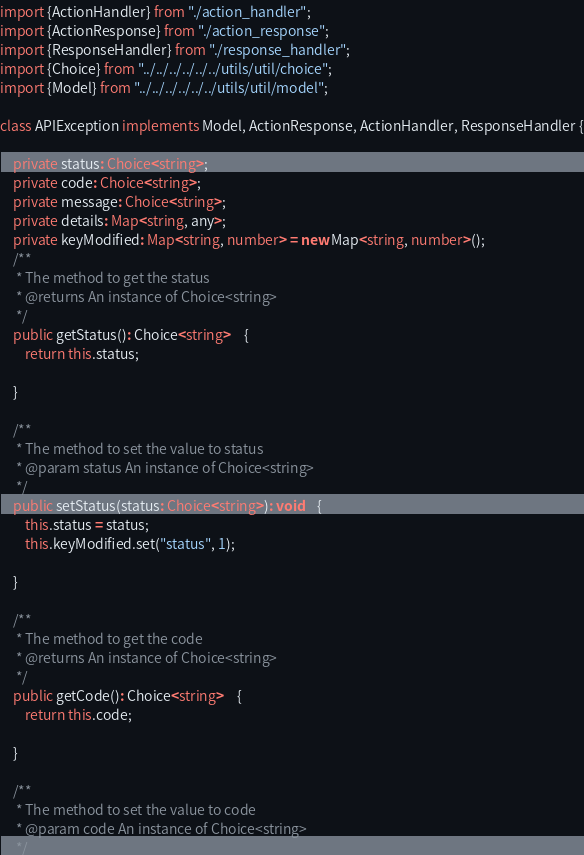<code> <loc_0><loc_0><loc_500><loc_500><_TypeScript_>import {ActionHandler} from "./action_handler";
import {ActionResponse} from "./action_response";
import {ResponseHandler} from "./response_handler";
import {Choice} from "../../../../../../utils/util/choice";
import {Model} from "../../../../../../utils/util/model";

class APIException implements Model, ActionResponse, ActionHandler, ResponseHandler {

	private status: Choice<string>;
	private code: Choice<string>;
	private message: Choice<string>;
	private details: Map<string, any>;
	private keyModified: Map<string, number> = new Map<string, number>();
	/**
	 * The method to get the status
	 * @returns An instance of Choice<string>
	 */
	public getStatus(): Choice<string>	{
		return this.status;

	}

	/**
	 * The method to set the value to status
	 * @param status An instance of Choice<string>
	 */
	public setStatus(status: Choice<string>): void	{
		this.status = status;
		this.keyModified.set("status", 1);

	}

	/**
	 * The method to get the code
	 * @returns An instance of Choice<string>
	 */
	public getCode(): Choice<string>	{
		return this.code;

	}

	/**
	 * The method to set the value to code
	 * @param code An instance of Choice<string>
	 */</code> 